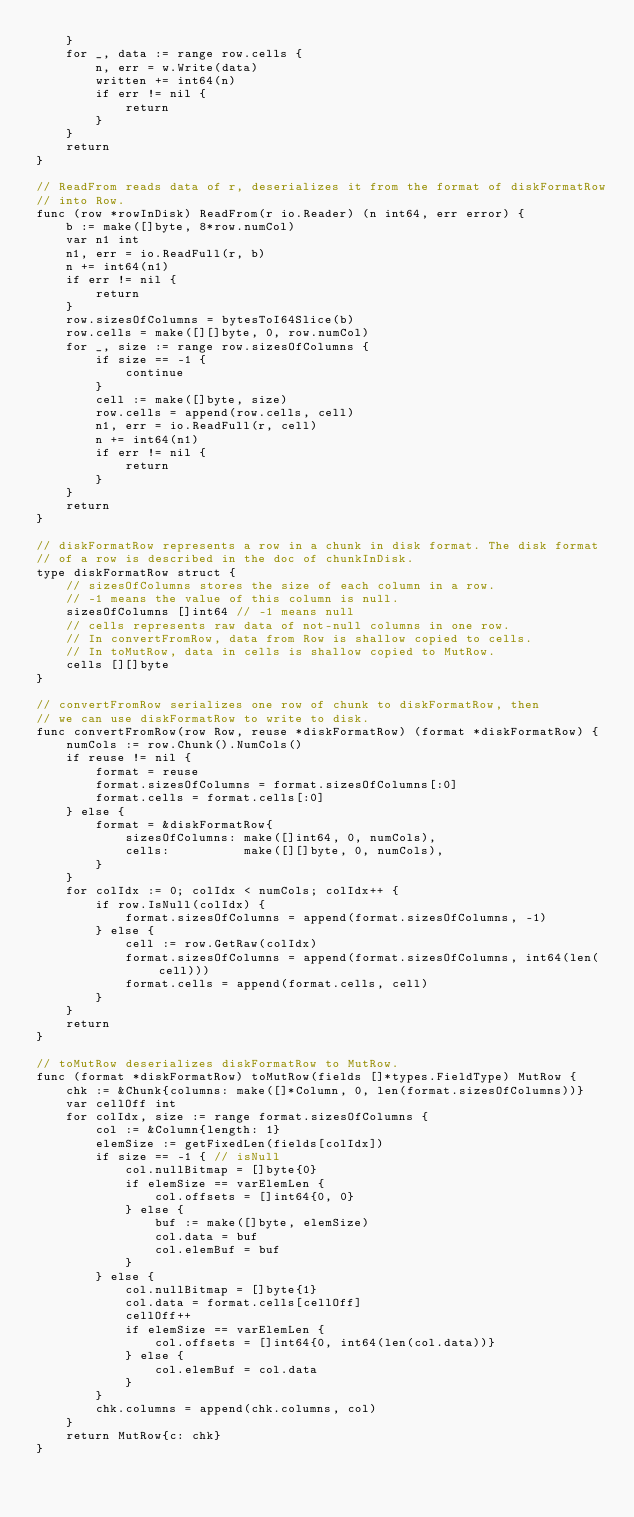Convert code to text. <code><loc_0><loc_0><loc_500><loc_500><_Go_>	}
	for _, data := range row.cells {
		n, err = w.Write(data)
		written += int64(n)
		if err != nil {
			return
		}
	}
	return
}

// ReadFrom reads data of r, deserializes it from the format of diskFormatRow
// into Row.
func (row *rowInDisk) ReadFrom(r io.Reader) (n int64, err error) {
	b := make([]byte, 8*row.numCol)
	var n1 int
	n1, err = io.ReadFull(r, b)
	n += int64(n1)
	if err != nil {
		return
	}
	row.sizesOfColumns = bytesToI64Slice(b)
	row.cells = make([][]byte, 0, row.numCol)
	for _, size := range row.sizesOfColumns {
		if size == -1 {
			continue
		}
		cell := make([]byte, size)
		row.cells = append(row.cells, cell)
		n1, err = io.ReadFull(r, cell)
		n += int64(n1)
		if err != nil {
			return
		}
	}
	return
}

// diskFormatRow represents a row in a chunk in disk format. The disk format
// of a row is described in the doc of chunkInDisk.
type diskFormatRow struct {
	// sizesOfColumns stores the size of each column in a row.
	// -1 means the value of this column is null.
	sizesOfColumns []int64 // -1 means null
	// cells represents raw data of not-null columns in one row.
	// In convertFromRow, data from Row is shallow copied to cells.
	// In toMutRow, data in cells is shallow copied to MutRow.
	cells [][]byte
}

// convertFromRow serializes one row of chunk to diskFormatRow, then
// we can use diskFormatRow to write to disk.
func convertFromRow(row Row, reuse *diskFormatRow) (format *diskFormatRow) {
	numCols := row.Chunk().NumCols()
	if reuse != nil {
		format = reuse
		format.sizesOfColumns = format.sizesOfColumns[:0]
		format.cells = format.cells[:0]
	} else {
		format = &diskFormatRow{
			sizesOfColumns: make([]int64, 0, numCols),
			cells:          make([][]byte, 0, numCols),
		}
	}
	for colIdx := 0; colIdx < numCols; colIdx++ {
		if row.IsNull(colIdx) {
			format.sizesOfColumns = append(format.sizesOfColumns, -1)
		} else {
			cell := row.GetRaw(colIdx)
			format.sizesOfColumns = append(format.sizesOfColumns, int64(len(cell)))
			format.cells = append(format.cells, cell)
		}
	}
	return
}

// toMutRow deserializes diskFormatRow to MutRow.
func (format *diskFormatRow) toMutRow(fields []*types.FieldType) MutRow {
	chk := &Chunk{columns: make([]*Column, 0, len(format.sizesOfColumns))}
	var cellOff int
	for colIdx, size := range format.sizesOfColumns {
		col := &Column{length: 1}
		elemSize := getFixedLen(fields[colIdx])
		if size == -1 { // isNull
			col.nullBitmap = []byte{0}
			if elemSize == varElemLen {
				col.offsets = []int64{0, 0}
			} else {
				buf := make([]byte, elemSize)
				col.data = buf
				col.elemBuf = buf
			}
		} else {
			col.nullBitmap = []byte{1}
			col.data = format.cells[cellOff]
			cellOff++
			if elemSize == varElemLen {
				col.offsets = []int64{0, int64(len(col.data))}
			} else {
				col.elemBuf = col.data
			}
		}
		chk.columns = append(chk.columns, col)
	}
	return MutRow{c: chk}
}
</code> 